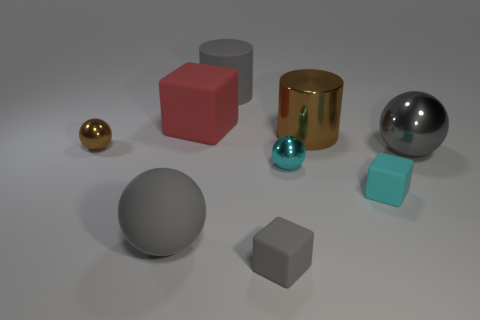Are the gray thing on the right side of the large brown thing and the tiny cyan ball made of the same material?
Your answer should be very brief. Yes. There is a big ball that is on the left side of the gray object that is in front of the big sphere in front of the small cyan block; what is it made of?
Give a very brief answer. Rubber. Is there anything else that is the same size as the cyan metal object?
Provide a short and direct response. Yes. How many rubber objects are tiny brown things or large gray cylinders?
Your answer should be compact. 1. Are there any big metal cylinders?
Ensure brevity in your answer.  Yes. There is a tiny sphere behind the metallic thing on the right side of the brown metal cylinder; what is its color?
Ensure brevity in your answer.  Brown. How many other objects are there of the same color as the large metallic ball?
Give a very brief answer. 3. How many objects are small blue cubes or small rubber things to the right of the large metallic cylinder?
Your answer should be compact. 1. What is the color of the small metallic ball that is left of the rubber cylinder?
Offer a terse response. Brown. There is a red rubber object; what shape is it?
Give a very brief answer. Cube. 